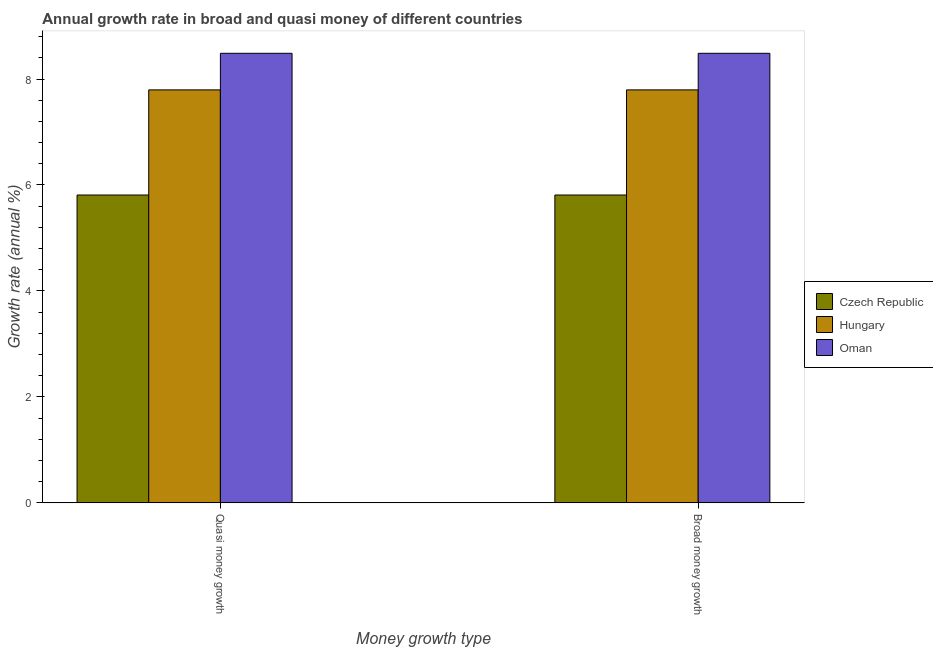How many different coloured bars are there?
Keep it short and to the point. 3. Are the number of bars per tick equal to the number of legend labels?
Your answer should be very brief. Yes. Are the number of bars on each tick of the X-axis equal?
Provide a succinct answer. Yes. What is the label of the 1st group of bars from the left?
Offer a terse response. Quasi money growth. What is the annual growth rate in broad money in Oman?
Keep it short and to the point. 8.49. Across all countries, what is the maximum annual growth rate in quasi money?
Your answer should be very brief. 8.49. Across all countries, what is the minimum annual growth rate in broad money?
Ensure brevity in your answer.  5.81. In which country was the annual growth rate in broad money maximum?
Ensure brevity in your answer.  Oman. In which country was the annual growth rate in quasi money minimum?
Your response must be concise. Czech Republic. What is the total annual growth rate in broad money in the graph?
Your answer should be very brief. 22.09. What is the difference between the annual growth rate in quasi money in Hungary and that in Oman?
Ensure brevity in your answer.  -0.69. What is the difference between the annual growth rate in quasi money in Czech Republic and the annual growth rate in broad money in Oman?
Keep it short and to the point. -2.68. What is the average annual growth rate in quasi money per country?
Offer a very short reply. 7.36. What is the difference between the annual growth rate in quasi money and annual growth rate in broad money in Czech Republic?
Your answer should be very brief. 0. In how many countries, is the annual growth rate in quasi money greater than 6.8 %?
Give a very brief answer. 2. What is the ratio of the annual growth rate in broad money in Hungary to that in Czech Republic?
Offer a terse response. 1.34. What does the 1st bar from the left in Broad money growth represents?
Offer a very short reply. Czech Republic. What does the 1st bar from the right in Broad money growth represents?
Your response must be concise. Oman. How many countries are there in the graph?
Keep it short and to the point. 3. What is the difference between two consecutive major ticks on the Y-axis?
Provide a succinct answer. 2. Are the values on the major ticks of Y-axis written in scientific E-notation?
Keep it short and to the point. No. How many legend labels are there?
Ensure brevity in your answer.  3. What is the title of the graph?
Your answer should be very brief. Annual growth rate in broad and quasi money of different countries. Does "Brunei Darussalam" appear as one of the legend labels in the graph?
Your response must be concise. No. What is the label or title of the X-axis?
Give a very brief answer. Money growth type. What is the label or title of the Y-axis?
Provide a succinct answer. Growth rate (annual %). What is the Growth rate (annual %) of Czech Republic in Quasi money growth?
Your answer should be very brief. 5.81. What is the Growth rate (annual %) in Hungary in Quasi money growth?
Your answer should be compact. 7.79. What is the Growth rate (annual %) in Oman in Quasi money growth?
Offer a terse response. 8.49. What is the Growth rate (annual %) of Czech Republic in Broad money growth?
Your answer should be very brief. 5.81. What is the Growth rate (annual %) of Hungary in Broad money growth?
Ensure brevity in your answer.  7.79. What is the Growth rate (annual %) in Oman in Broad money growth?
Provide a succinct answer. 8.49. Across all Money growth type, what is the maximum Growth rate (annual %) of Czech Republic?
Provide a succinct answer. 5.81. Across all Money growth type, what is the maximum Growth rate (annual %) of Hungary?
Give a very brief answer. 7.79. Across all Money growth type, what is the maximum Growth rate (annual %) of Oman?
Keep it short and to the point. 8.49. Across all Money growth type, what is the minimum Growth rate (annual %) in Czech Republic?
Give a very brief answer. 5.81. Across all Money growth type, what is the minimum Growth rate (annual %) in Hungary?
Keep it short and to the point. 7.79. Across all Money growth type, what is the minimum Growth rate (annual %) of Oman?
Your response must be concise. 8.49. What is the total Growth rate (annual %) in Czech Republic in the graph?
Give a very brief answer. 11.62. What is the total Growth rate (annual %) of Hungary in the graph?
Offer a terse response. 15.59. What is the total Growth rate (annual %) of Oman in the graph?
Provide a succinct answer. 16.97. What is the difference between the Growth rate (annual %) of Czech Republic in Quasi money growth and that in Broad money growth?
Ensure brevity in your answer.  0. What is the difference between the Growth rate (annual %) in Hungary in Quasi money growth and that in Broad money growth?
Give a very brief answer. 0. What is the difference between the Growth rate (annual %) in Oman in Quasi money growth and that in Broad money growth?
Your answer should be compact. 0. What is the difference between the Growth rate (annual %) of Czech Republic in Quasi money growth and the Growth rate (annual %) of Hungary in Broad money growth?
Provide a succinct answer. -1.98. What is the difference between the Growth rate (annual %) in Czech Republic in Quasi money growth and the Growth rate (annual %) in Oman in Broad money growth?
Make the answer very short. -2.68. What is the difference between the Growth rate (annual %) in Hungary in Quasi money growth and the Growth rate (annual %) in Oman in Broad money growth?
Offer a very short reply. -0.69. What is the average Growth rate (annual %) in Czech Republic per Money growth type?
Give a very brief answer. 5.81. What is the average Growth rate (annual %) of Hungary per Money growth type?
Offer a terse response. 7.79. What is the average Growth rate (annual %) of Oman per Money growth type?
Your response must be concise. 8.49. What is the difference between the Growth rate (annual %) in Czech Republic and Growth rate (annual %) in Hungary in Quasi money growth?
Offer a terse response. -1.98. What is the difference between the Growth rate (annual %) of Czech Republic and Growth rate (annual %) of Oman in Quasi money growth?
Your answer should be compact. -2.68. What is the difference between the Growth rate (annual %) in Hungary and Growth rate (annual %) in Oman in Quasi money growth?
Ensure brevity in your answer.  -0.69. What is the difference between the Growth rate (annual %) in Czech Republic and Growth rate (annual %) in Hungary in Broad money growth?
Provide a succinct answer. -1.98. What is the difference between the Growth rate (annual %) in Czech Republic and Growth rate (annual %) in Oman in Broad money growth?
Offer a very short reply. -2.68. What is the difference between the Growth rate (annual %) of Hungary and Growth rate (annual %) of Oman in Broad money growth?
Your response must be concise. -0.69. What is the ratio of the Growth rate (annual %) in Czech Republic in Quasi money growth to that in Broad money growth?
Your response must be concise. 1. What is the ratio of the Growth rate (annual %) of Oman in Quasi money growth to that in Broad money growth?
Ensure brevity in your answer.  1. What is the difference between the highest and the second highest Growth rate (annual %) of Czech Republic?
Ensure brevity in your answer.  0. What is the difference between the highest and the second highest Growth rate (annual %) in Oman?
Ensure brevity in your answer.  0. What is the difference between the highest and the lowest Growth rate (annual %) in Hungary?
Your response must be concise. 0. What is the difference between the highest and the lowest Growth rate (annual %) of Oman?
Your answer should be compact. 0. 